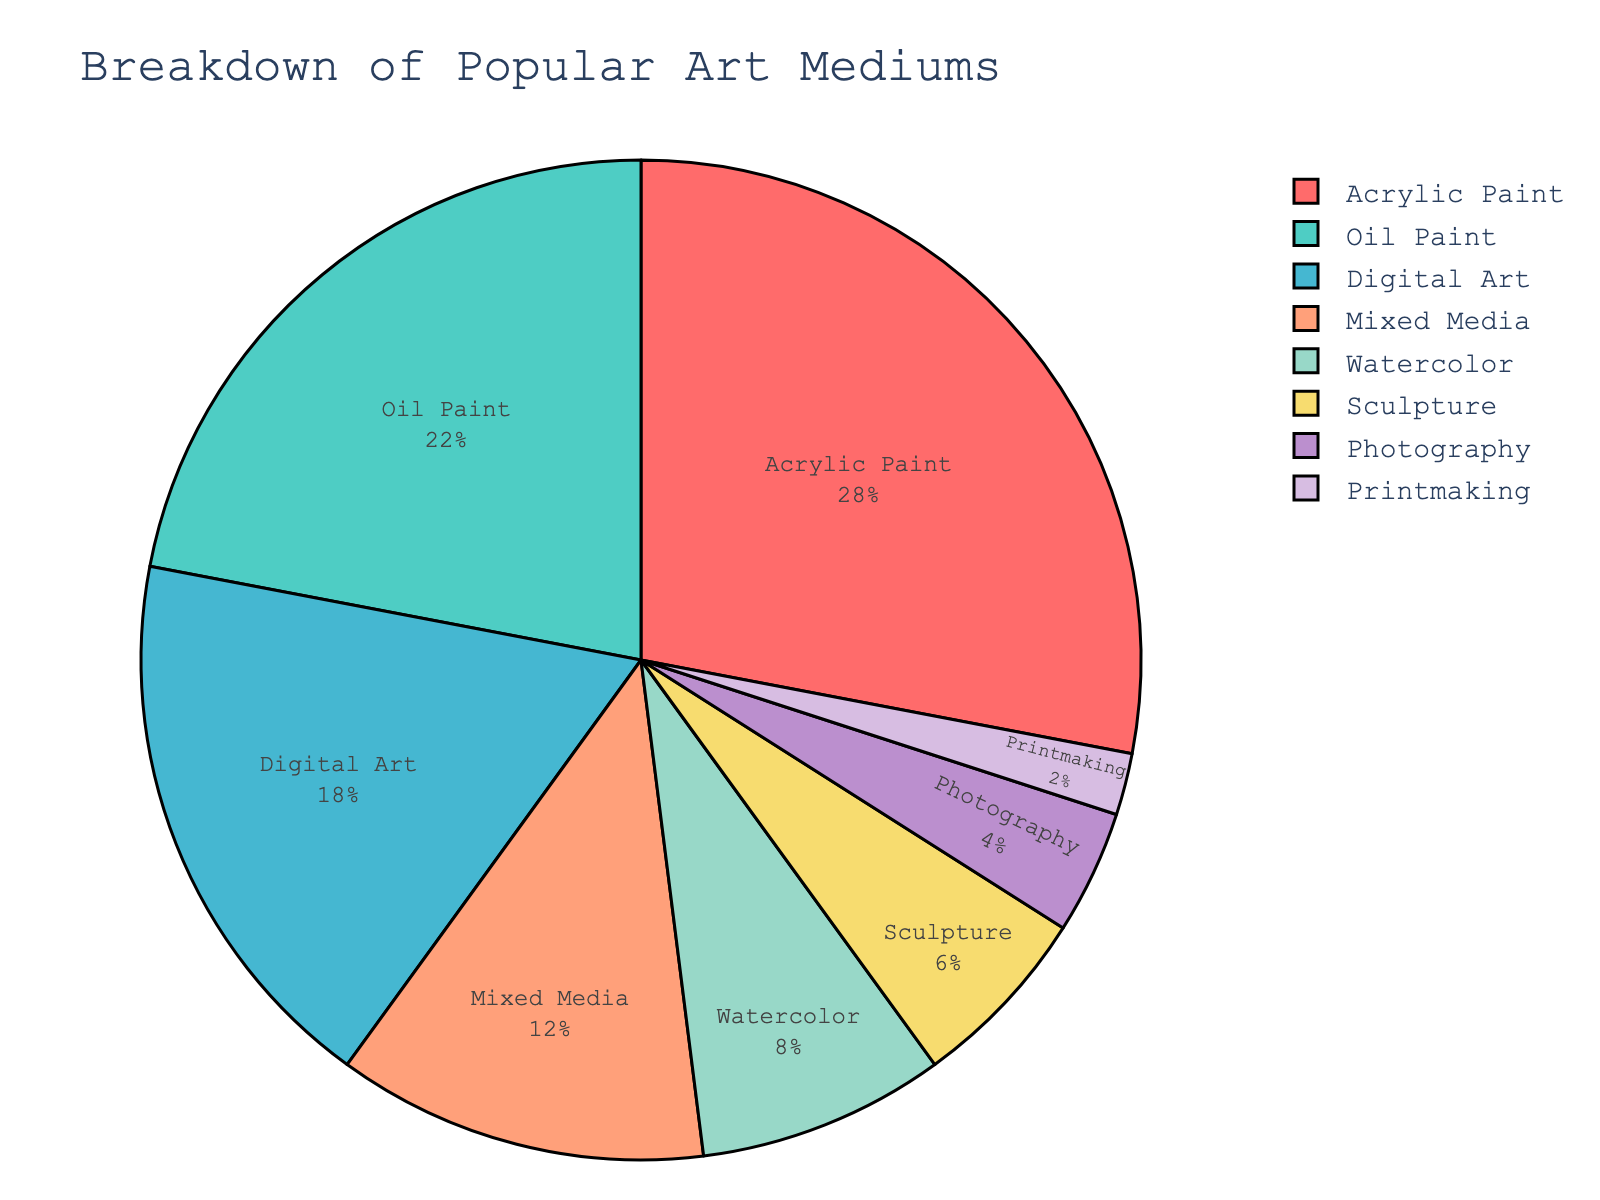What are the two most popular art mediums? The two segments with the largest percentages represent the most popular mediums. According to the chart, Acrylic Paint (28%) and Oil Paint (22%) are the largest segments.
Answer: Acrylic Paint and Oil Paint Which medium has the least usage among contemporary artists? The smallest segment in the pie chart represents the medium with the least usage. The chart shows Printmaking has the smallest segment at 2%.
Answer: Printmaking How much more popular is Acrylic Paint compared to Digital Art? Find the percentage of Acrylic Paint and Digital Art, then subtract the smaller percentage from the larger. Acrylic Paint is 28%, and Digital Art is 18%. So, 28% - 18% = 10%.
Answer: 10% Which medium is used more: Sculpture or Photography? Compare the segments for Sculpture and Photography. Sculpture has a percentage of 6%, whereas Photography has 4%.
Answer: Sculpture What is the combined percentage of Mixed Media and Watercolor usage? Add the percentages of Mixed Media and Watercolor. Mixed Media is 12%, and Watercolor is 8%. So, 12% + 8% = 20%.
Answer: 20% How many mediums have a usage percentage less than 10%? Identify the segments with less than 10% usage. Watercolor (8%), Sculpture (6%), Photography (4%), and Printmaking (2%) are less than 10%.
Answer: 4 What percentage of mediums is comprised by top three most popular mediums? Sum the percentages of the top three segments. Acrylic Paint (28%), Oil Paint (22%), and Digital Art (18%). 28% + 22% + 18% = 68%.
Answer: 68% What is the difference between the usage of Oil Paint and Sculpture? Subtract the percentage of Sculpture from the percentage of Oil Paint. Oil Paint is 22%, and Sculpture is 6%. So, 22% - 6% = 16%.
Answer: 16% Which medium appears the third most popular in the breakdown? Identify the third largest segment in the pie chart. Acrylic Paint is first, Oil Paint is second, and Digital Art is third.
Answer: Digital Art How does the popularity of Watercolor compare to Mixed Media? Compare the segments for Watercolor and Mixed Media. Watercolor has a percentage of 8%, whereas Mixed Media has 12%. So, Mixed Media is more popular.
Answer: Mixed Media 